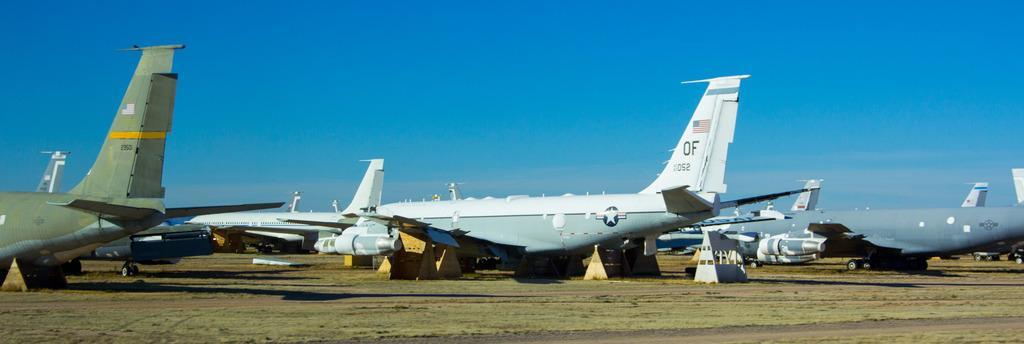In one or two sentences, can you explain what this image depicts? In this image we can see aeroplanes on the ground. In the background there is sky with clouds. 